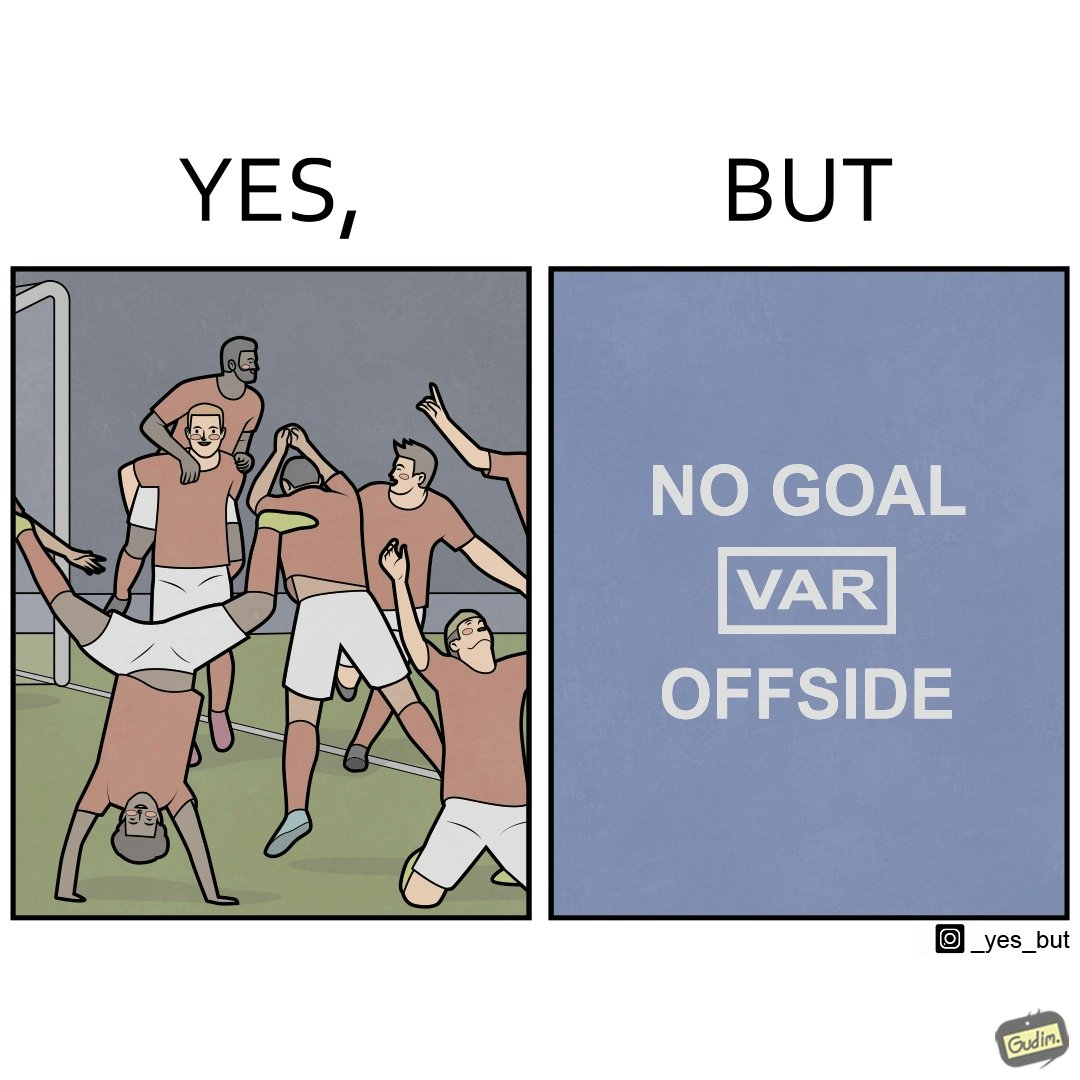Explain the humor or irony in this image. The image is ironical, as the team is celebrating as they think that they have scored a goal, but the sign on the screen says that it is an offside, and not a goal. This is a very common scenario in football matches. 